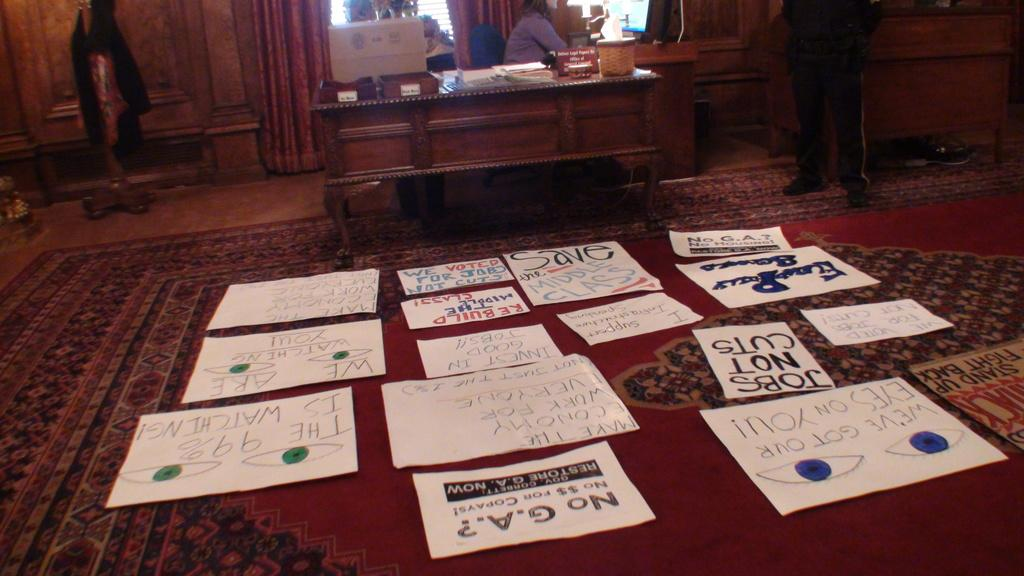What type of furniture is present in the image? There is a table in the image. What is on the floor in the image? There are papers on the floor in the image. What type of floor covering is visible in the image? There is a mat in the image. What type of market is depicted in the image? There is no market present in the image; it only features a table, papers on the floor, and a mat. What type of approval is required to enter the room in the image? There is no indication of any approval process required to enter the room in the image. 